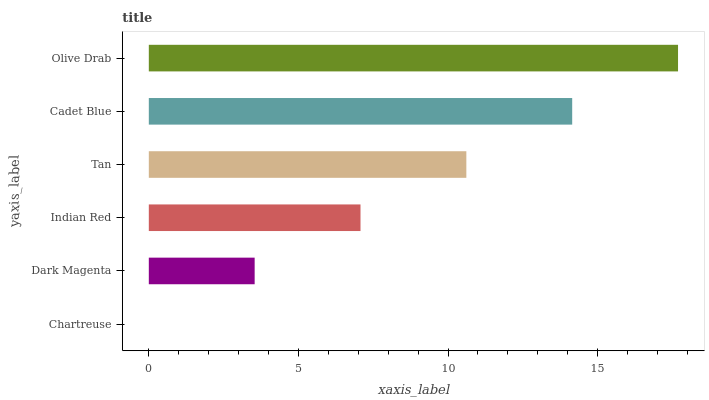Is Chartreuse the minimum?
Answer yes or no. Yes. Is Olive Drab the maximum?
Answer yes or no. Yes. Is Dark Magenta the minimum?
Answer yes or no. No. Is Dark Magenta the maximum?
Answer yes or no. No. Is Dark Magenta greater than Chartreuse?
Answer yes or no. Yes. Is Chartreuse less than Dark Magenta?
Answer yes or no. Yes. Is Chartreuse greater than Dark Magenta?
Answer yes or no. No. Is Dark Magenta less than Chartreuse?
Answer yes or no. No. Is Tan the high median?
Answer yes or no. Yes. Is Indian Red the low median?
Answer yes or no. Yes. Is Dark Magenta the high median?
Answer yes or no. No. Is Tan the low median?
Answer yes or no. No. 